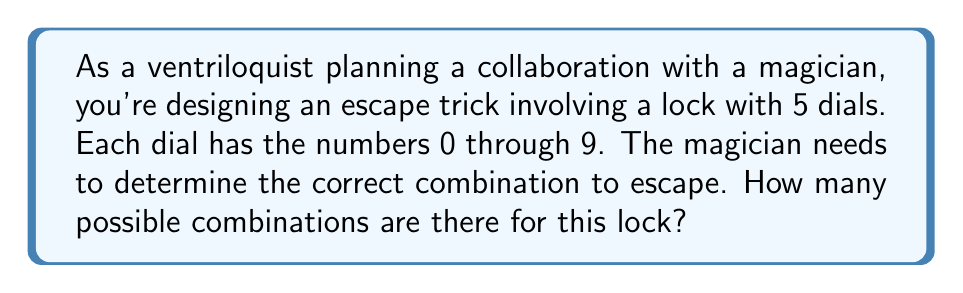Give your solution to this math problem. Let's approach this step-by-step:

1) Each dial has 10 possible positions (0 through 9).

2) There are 5 dials in total.

3) For each position of the first dial, we have 10 choices for the second dial, 10 for the third, and so on.

4) This scenario follows the multiplication principle of counting.

5) The total number of combinations can be calculated as:

   $$10 \times 10 \times 10 \times 10 \times 10$$

6) This is equivalent to:

   $$10^5$$

7) Calculating this:
   
   $$10^5 = 100,000$$

Therefore, there are 100,000 possible combinations for the lock.
Answer: 100,000 